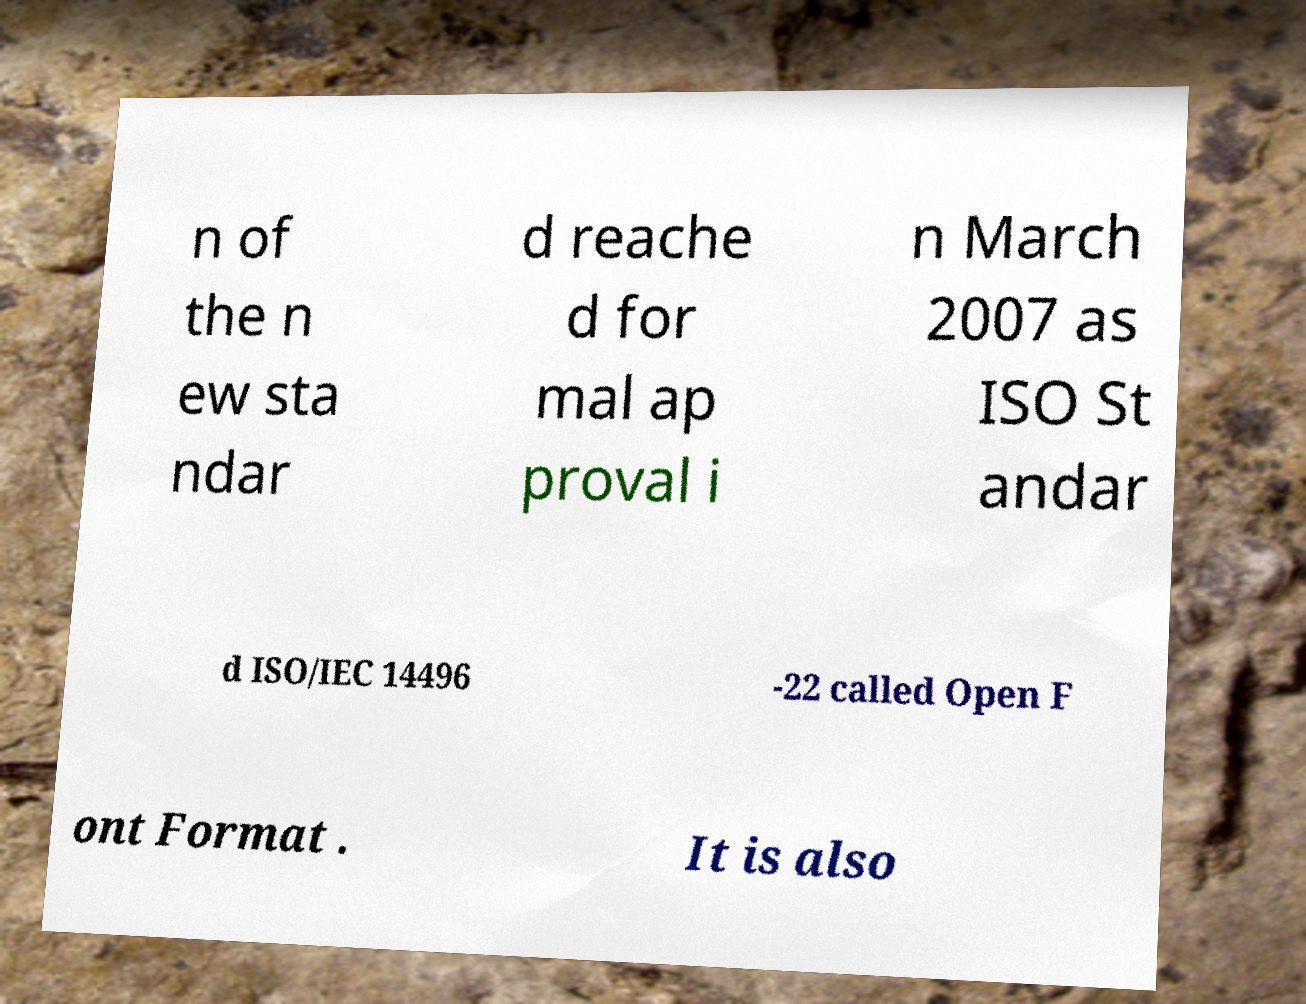Please identify and transcribe the text found in this image. n of the n ew sta ndar d reache d for mal ap proval i n March 2007 as ISO St andar d ISO/IEC 14496 -22 called Open F ont Format . It is also 